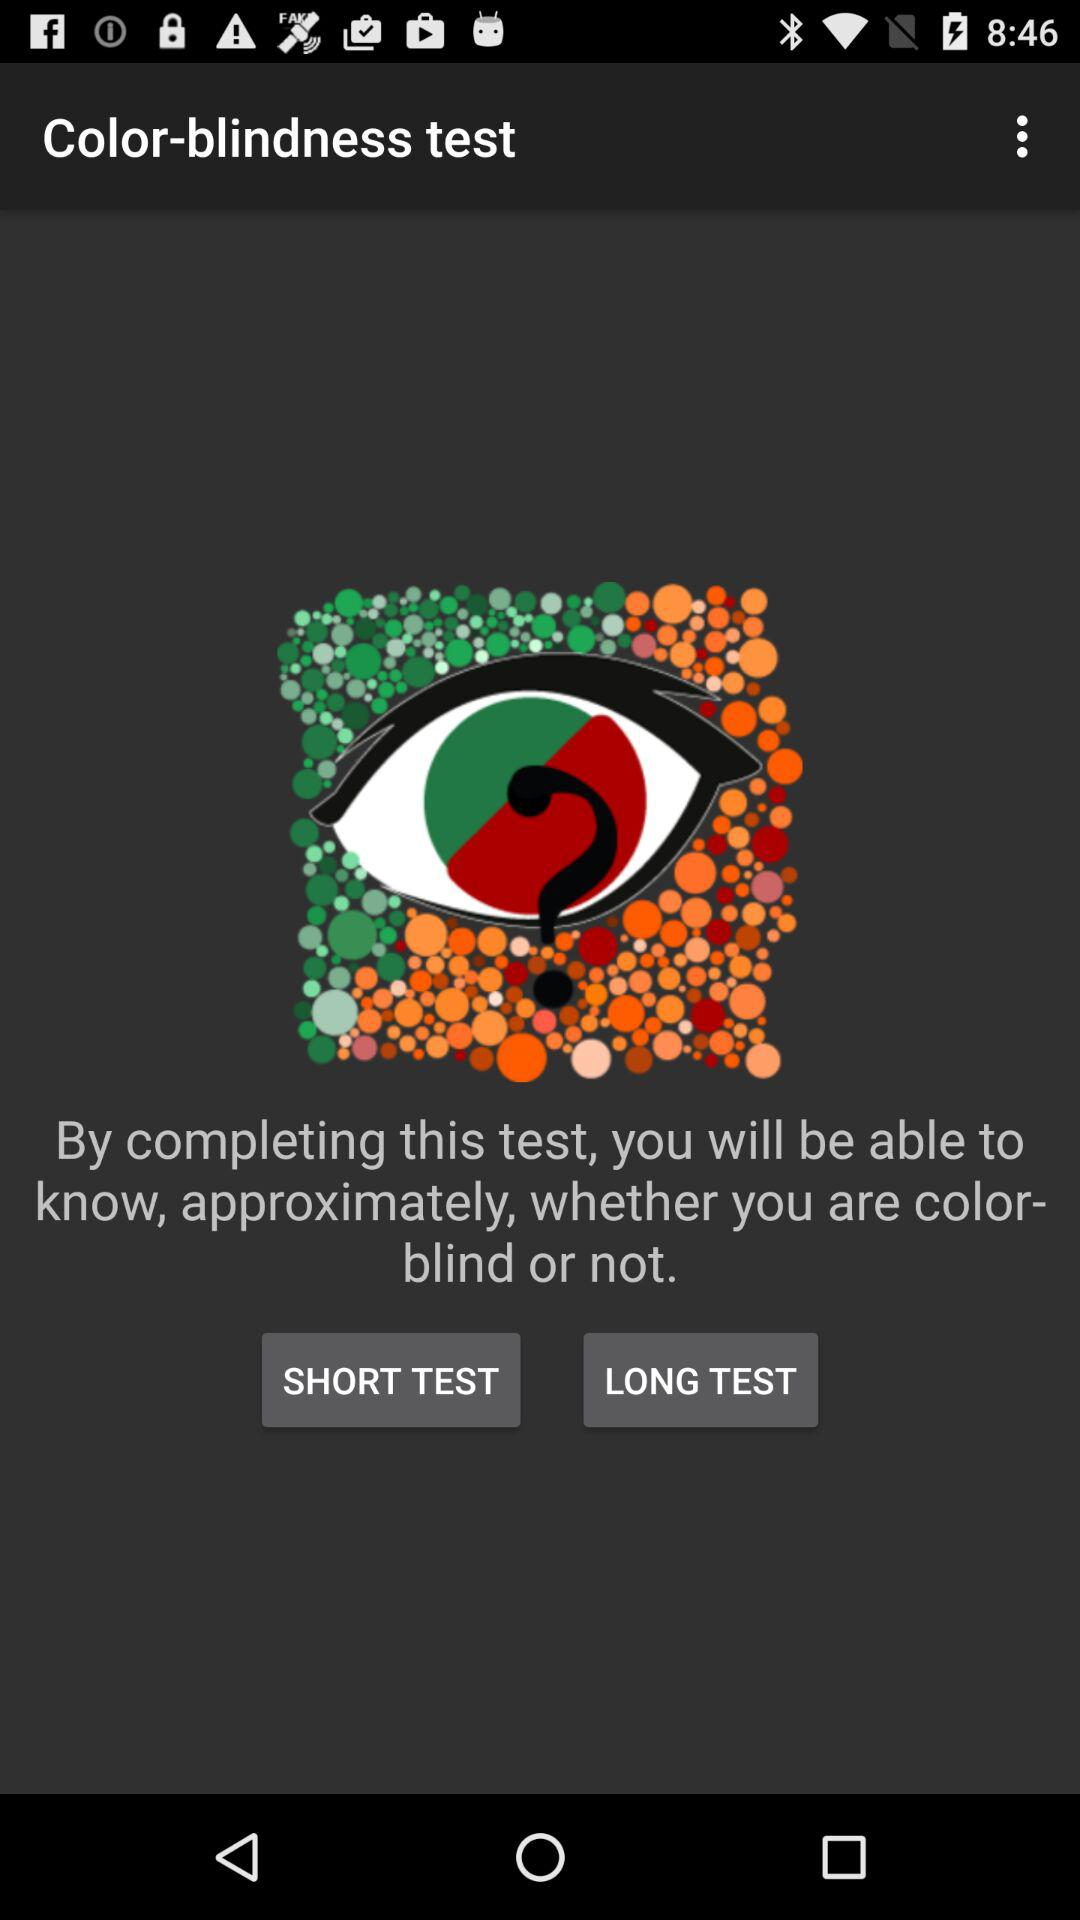How many test questions are there for color-blindness?
When the provided information is insufficient, respond with <no answer>. <no answer> 